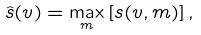<formula> <loc_0><loc_0><loc_500><loc_500>\hat { s } ( v ) = \max _ { m } \left [ s ( v , m ) \right ] ,</formula> 